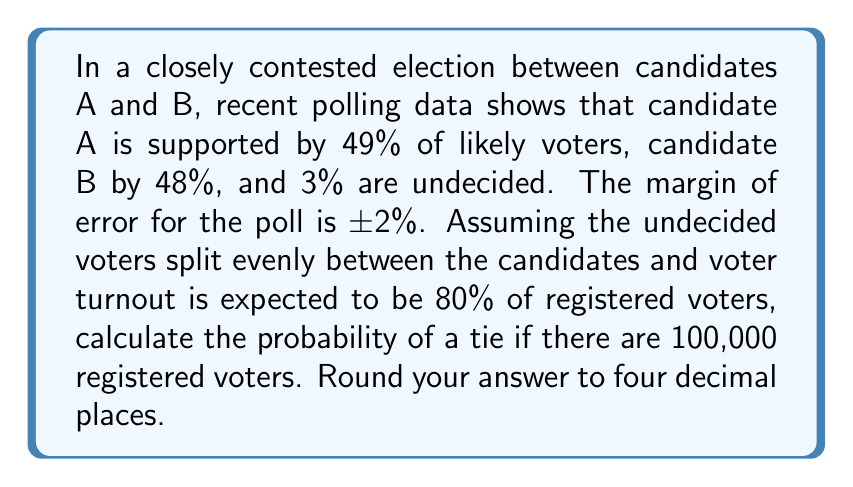Teach me how to tackle this problem. Let's approach this step-by-step:

1) First, we need to calculate the expected number of voters:
   $100,000 \times 0.80 = 80,000$ expected voters

2) Now, let's calculate the expected votes for each candidate:
   Candidate A: $80,000 \times (0.49 + 0.015) = 40,400$
   Candidate B: $80,000 \times (0.48 + 0.015) = 39,600$

3) For a tie to occur, we need exactly 40,000 votes for each candidate. We can model this as a binomial distribution with $n = 80,000$ trials and $p = 0.5$ (since we're assuming equal probability for each candidate in a tie scenario).

4) The probability of exactly 40,000 successes in 80,000 trials with $p = 0.5$ is given by:

   $$P(X = 40000) = \binom{80000}{40000} (0.5)^{40000} (0.5)^{40000}$$

5) We can calculate this using the normal approximation to the binomial distribution:
   $\mu = np = 80000 \times 0.5 = 40000$
   $\sigma = \sqrt{np(1-p)} = \sqrt{80000 \times 0.5 \times 0.5} = 100$

6) Using the continuity correction:
   $$P(39999.5 < X < 40000.5) = P(-0.005 < Z < 0.005)$$

7) Looking up the Z-score in a standard normal table:
   $P(-0.005 < Z < 0.005) \approx 0.004$

8) Therefore, the probability of a tie is approximately 0.0040 or 0.40%.
Answer: 0.0040 